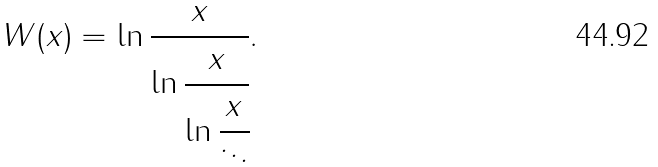<formula> <loc_0><loc_0><loc_500><loc_500>W ( x ) = \ln { \cfrac { x } { \ln { \cfrac { x } { \ln { \cfrac { x } { \ddots } } } } } } .</formula> 